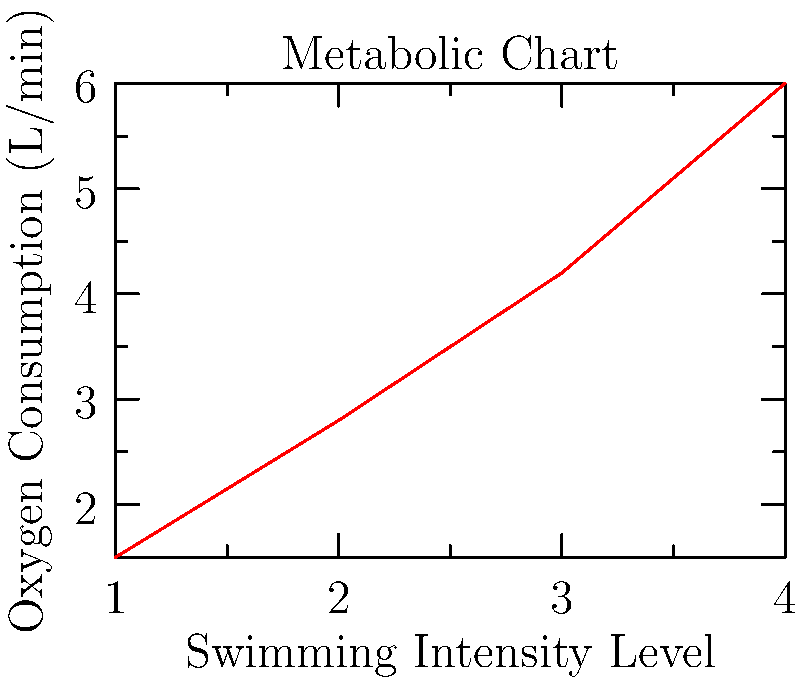Using the metabolic chart provided, calculate the rate of change in oxygen consumption between swimming intensity levels 2 and 4. Express your answer in liters per minute per intensity level. To solve this problem, we need to follow these steps:

1. Identify the oxygen consumption values for intensity levels 2 and 4:
   - At intensity level 2: $y_1 = 2.8$ L/min
   - At intensity level 4: $y_2 = 6.0$ L/min

2. Calculate the change in oxygen consumption:
   $\Delta y = y_2 - y_1 = 6.0 - 2.8 = 3.2$ L/min

3. Determine the change in intensity levels:
   $\Delta x = x_2 - x_1 = 4 - 2 = 2$ levels

4. Calculate the rate of change using the formula:
   Rate of change = $\frac{\Delta y}{\Delta x}$

5. Substitute the values:
   Rate of change = $\frac{3.2 \text{ L/min}}{2 \text{ levels}}$

6. Simplify:
   Rate of change = $1.6$ L/min per intensity level

Therefore, the rate of change in oxygen consumption between swimming intensity levels 2 and 4 is 1.6 liters per minute per intensity level.
Answer: 1.6 L/min per intensity level 